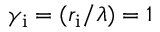Convert formula to latex. <formula><loc_0><loc_0><loc_500><loc_500>\gamma _ { i } = ( r _ { i } / \lambda ) = 1</formula> 